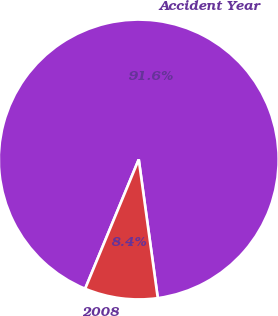Convert chart to OTSL. <chart><loc_0><loc_0><loc_500><loc_500><pie_chart><fcel>Accident Year<fcel>2008<nl><fcel>91.57%<fcel>8.43%<nl></chart> 